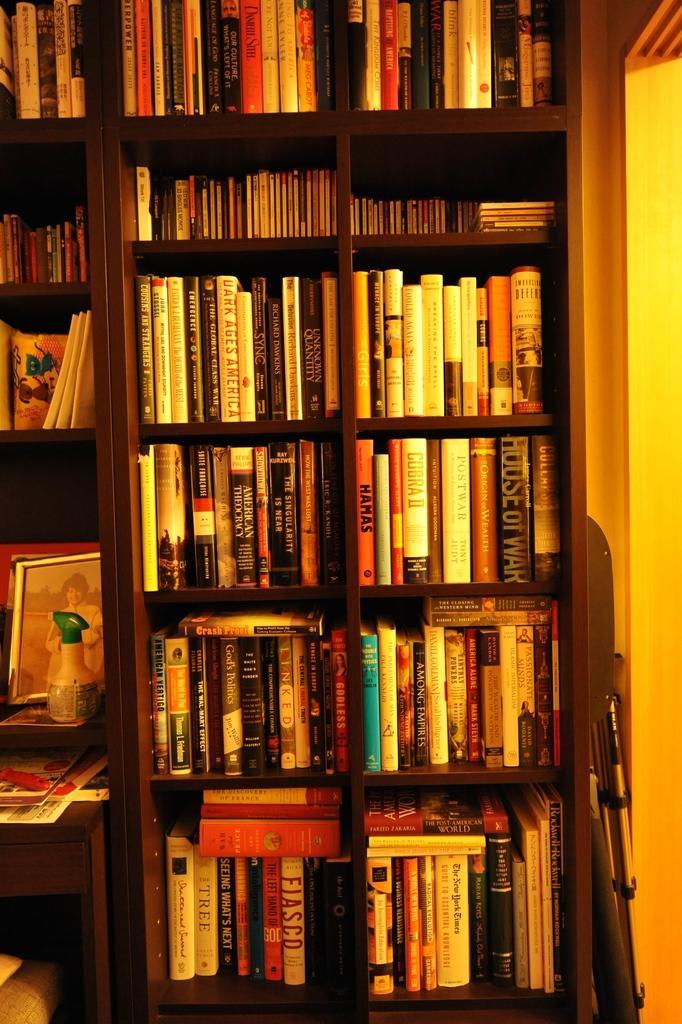In one or two sentences, can you explain what this image depicts? In this picture we can see lots of books, a photo frame and a bottle in the shelves. On the right side of the shelves there is an object. 